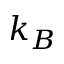<formula> <loc_0><loc_0><loc_500><loc_500>k _ { B }</formula> 